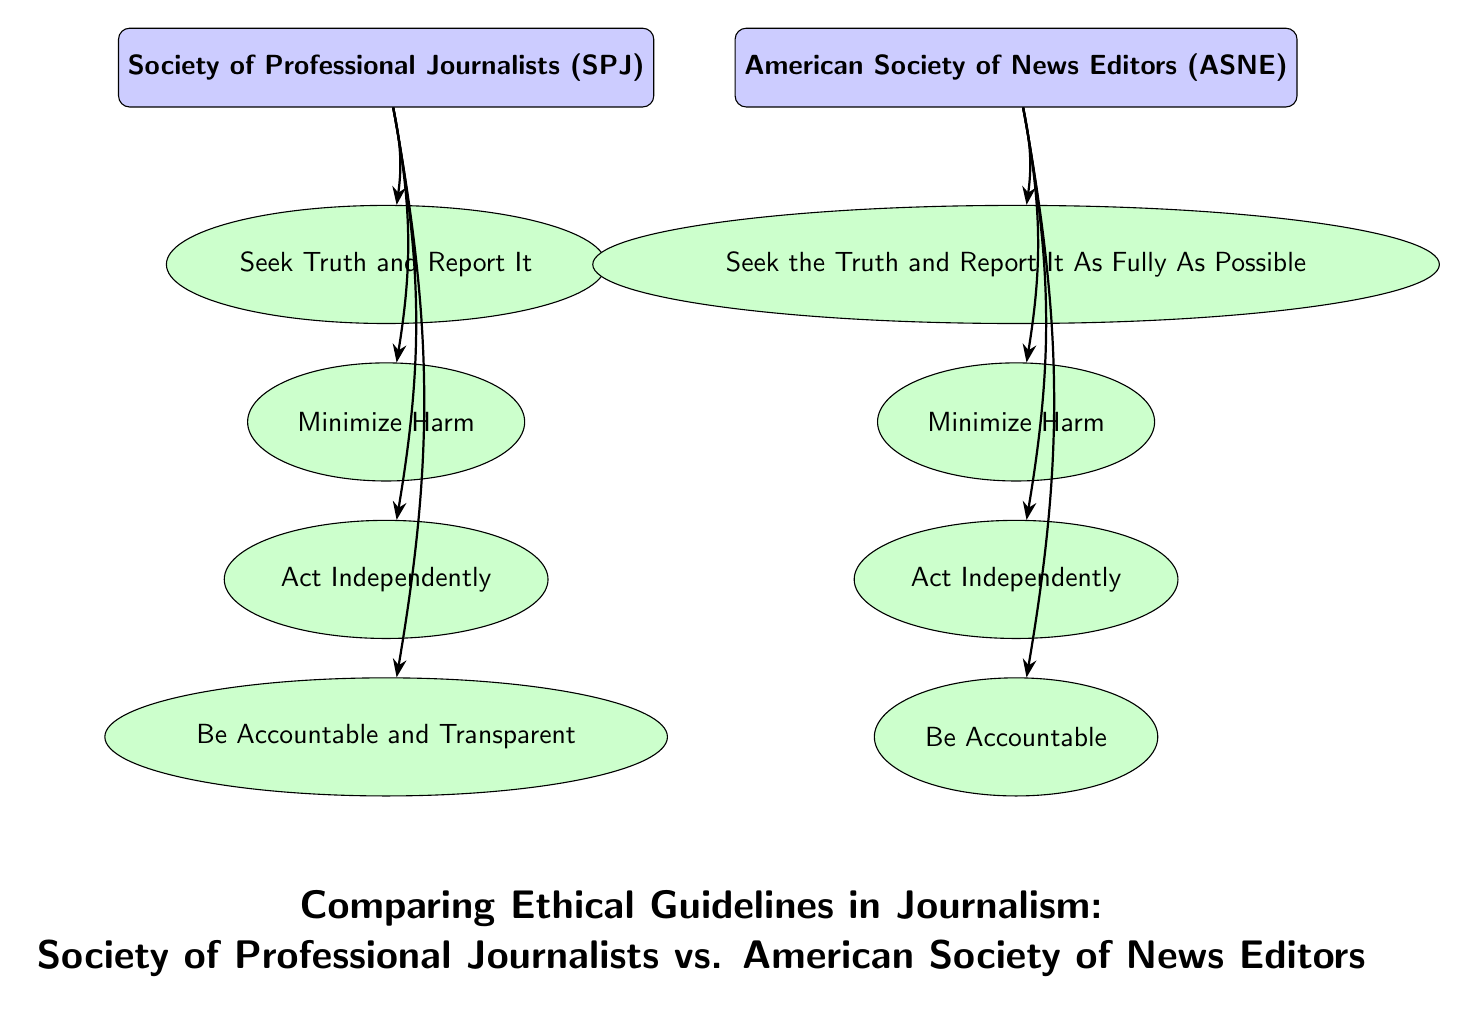What are the two organizations compared in the diagram? The two organizations depicted in the diagram are clearly labeled at the top as the Society of Professional Journalists (SPJ) on the left and the American Society of News Editors (ASNE) on the right.
Answer: Society of Professional Journalists, American Society of News Editors How many principles does the Society of Professional Journalists have? By counting the principles listed under the Society of Professional Journalists in the diagram, there are a total of four principles displayed, each connected by an arrow.
Answer: 4 What is the principle shared by both organizations? The principle "Minimize Harm" is present in both the Society of Professional Journalists and the American Society of News Editors, indicating a shared ethical guideline, which connects both organizations.
Answer: Minimize Harm Which principle from ASNE emphasizes a more complete approach to reporting truth? The principle "Seek the Truth and Report It As Fully As Possible" specifically highlights a more comprehensive approach to truth-telling, distinguishing it from the SPJ's phrasing. This is evident in the ASNE's section of the diagram.
Answer: Seek the Truth and Report It As Fully As Possible What is the last principle for the Society of Professional Journalists? The last principle listed under the Society of Professional Journalists is "Be Accountable and Transparent", which is located at the bottom of the SPJ section in the diagram.
Answer: Be Accountable and Transparent Explain the difference between the accountability principles of SPJ and ASNE. In the diagram, the Society of Professional Journalists has "Be Accountable and Transparent" as their last principle, while the American Society of News Editors has "Be Accountable". The difference lies in the inclusion of "Transparent" in the SPJ principle, indicating a higher standard of accountability.
Answer: Be Accountable and Transparent (SPJ), Be Accountable (ASNE) 